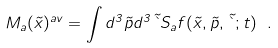Convert formula to latex. <formula><loc_0><loc_0><loc_500><loc_500>M _ { a } ( { \vec { x } } ) ^ { a v } = \int d ^ { 3 } { \vec { p } } d ^ { 3 } { \vec { \theta } } S _ { a } f ( { \vec { x } } , { \vec { p } } , { \vec { \theta } } ; t ) \ .</formula> 